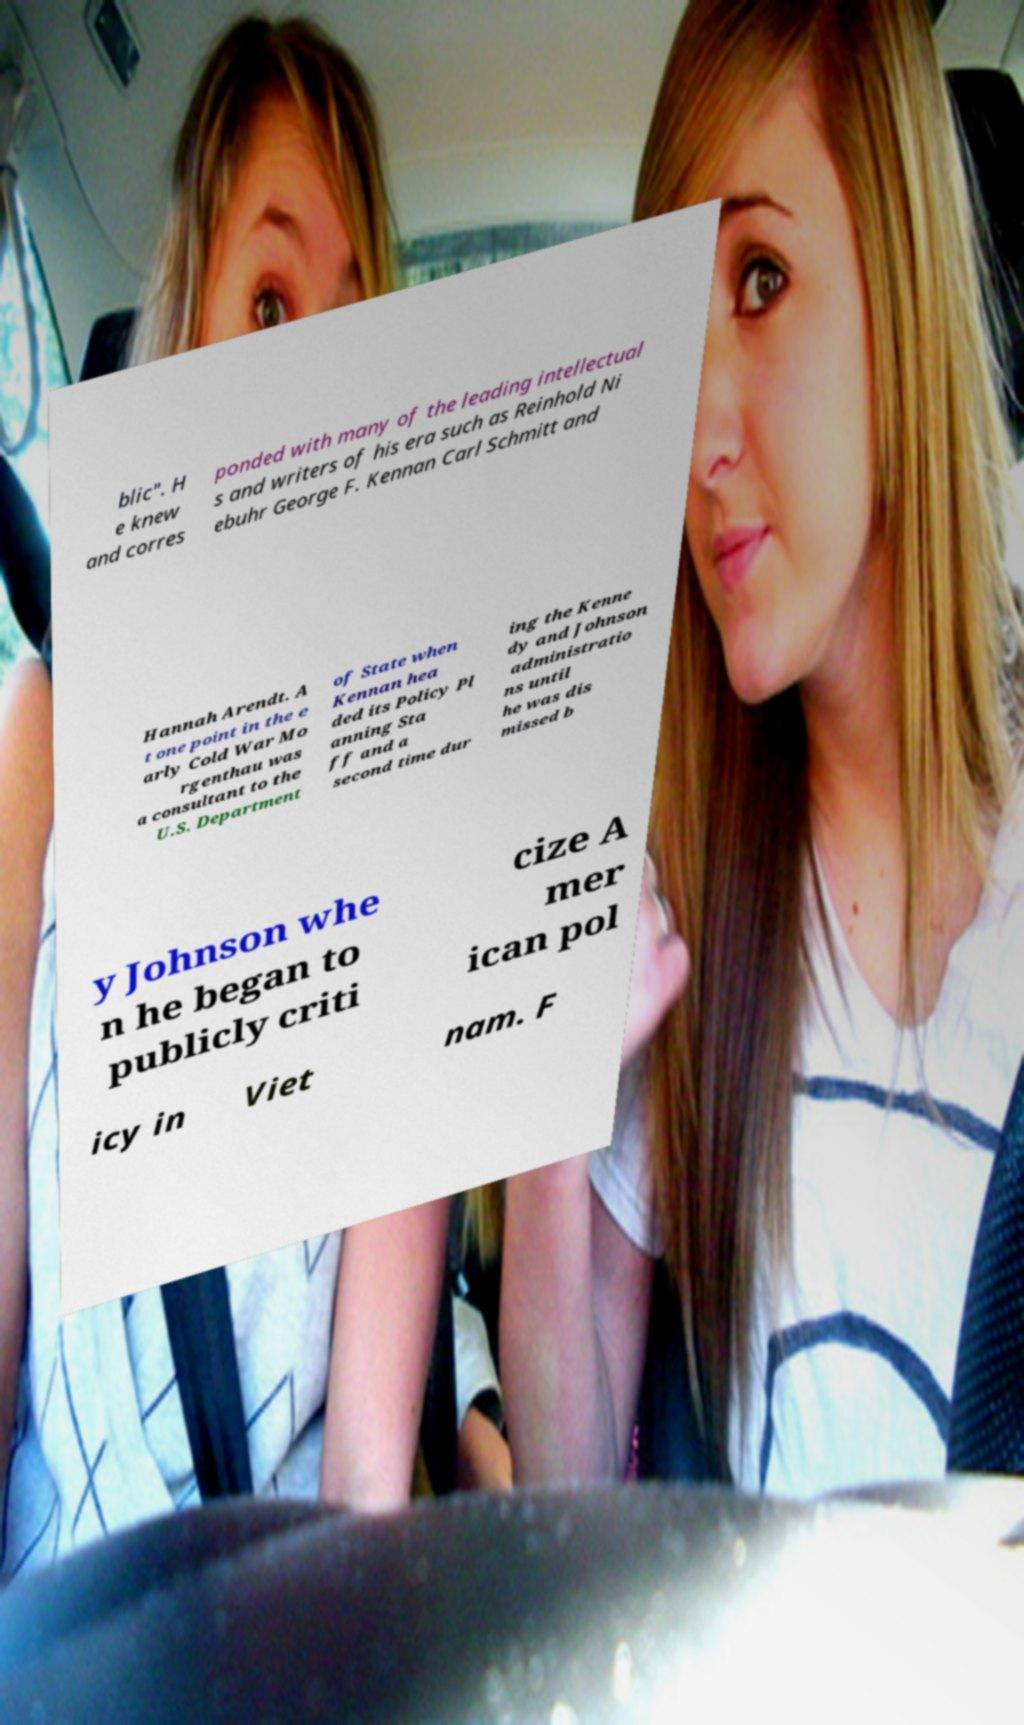For documentation purposes, I need the text within this image transcribed. Could you provide that? blic". H e knew and corres ponded with many of the leading intellectual s and writers of his era such as Reinhold Ni ebuhr George F. Kennan Carl Schmitt and Hannah Arendt. A t one point in the e arly Cold War Mo rgenthau was a consultant to the U.S. Department of State when Kennan hea ded its Policy Pl anning Sta ff and a second time dur ing the Kenne dy and Johnson administratio ns until he was dis missed b y Johnson whe n he began to publicly criti cize A mer ican pol icy in Viet nam. F 